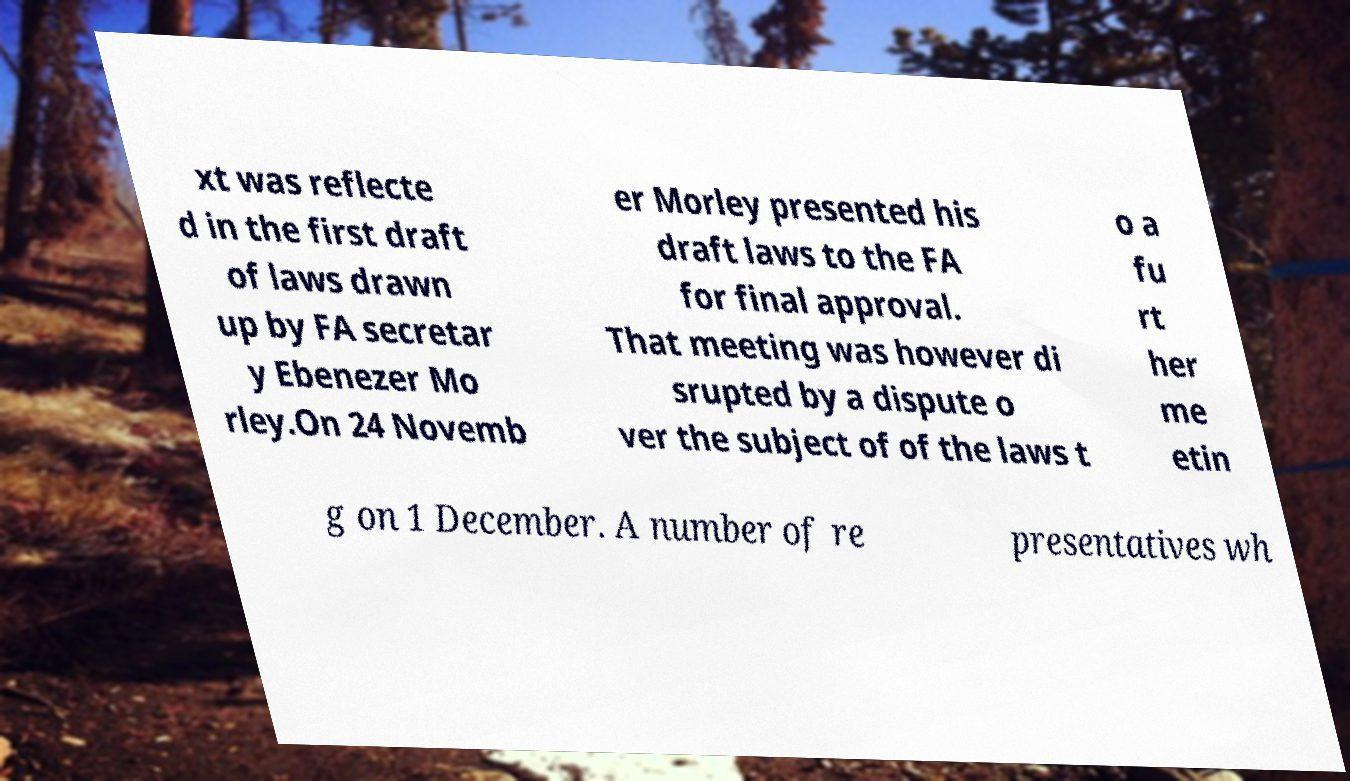Could you assist in decoding the text presented in this image and type it out clearly? xt was reflecte d in the first draft of laws drawn up by FA secretar y Ebenezer Mo rley.On 24 Novemb er Morley presented his draft laws to the FA for final approval. That meeting was however di srupted by a dispute o ver the subject of of the laws t o a fu rt her me etin g on 1 December. A number of re presentatives wh 